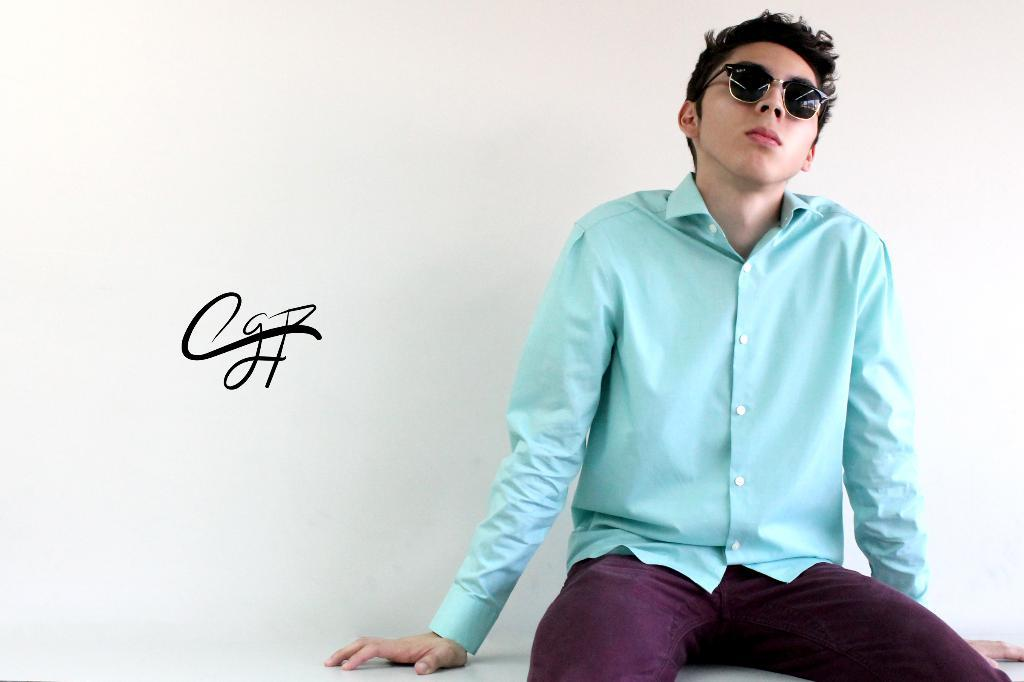Who is present in the image? There is a man in the image. What is the man wearing? The man is wearing glasses. What is the man doing in the image? The man is sitting. What can be seen in the background of the image? There is a wall in the background of the image. What type of roof is visible on the school in the image? There is no school or roof present in the image; it features a man sitting with glasses on. 